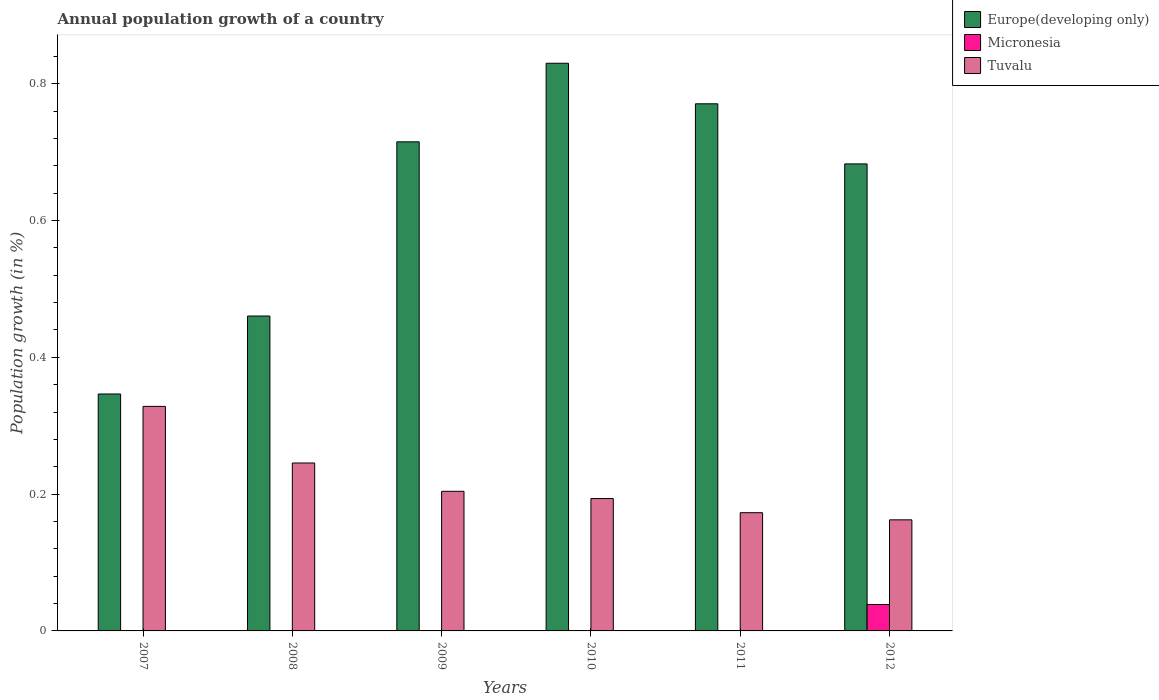How many different coloured bars are there?
Offer a terse response. 3. How many groups of bars are there?
Keep it short and to the point. 6. Are the number of bars per tick equal to the number of legend labels?
Ensure brevity in your answer.  No. How many bars are there on the 5th tick from the left?
Your answer should be compact. 2. What is the annual population growth in Europe(developing only) in 2009?
Offer a very short reply. 0.72. Across all years, what is the maximum annual population growth in Europe(developing only)?
Offer a terse response. 0.83. Across all years, what is the minimum annual population growth in Tuvalu?
Ensure brevity in your answer.  0.16. What is the total annual population growth in Micronesia in the graph?
Your answer should be very brief. 0.04. What is the difference between the annual population growth in Europe(developing only) in 2008 and that in 2009?
Your response must be concise. -0.25. What is the difference between the annual population growth in Micronesia in 2009 and the annual population growth in Europe(developing only) in 2012?
Ensure brevity in your answer.  -0.68. What is the average annual population growth in Micronesia per year?
Your answer should be very brief. 0.01. In the year 2007, what is the difference between the annual population growth in Tuvalu and annual population growth in Europe(developing only)?
Offer a terse response. -0.02. What is the ratio of the annual population growth in Tuvalu in 2007 to that in 2009?
Ensure brevity in your answer.  1.61. Is the annual population growth in Europe(developing only) in 2007 less than that in 2009?
Ensure brevity in your answer.  Yes. Is the difference between the annual population growth in Tuvalu in 2008 and 2010 greater than the difference between the annual population growth in Europe(developing only) in 2008 and 2010?
Offer a terse response. Yes. What is the difference between the highest and the second highest annual population growth in Europe(developing only)?
Provide a short and direct response. 0.06. What is the difference between the highest and the lowest annual population growth in Tuvalu?
Ensure brevity in your answer.  0.17. In how many years, is the annual population growth in Micronesia greater than the average annual population growth in Micronesia taken over all years?
Ensure brevity in your answer.  1. Is it the case that in every year, the sum of the annual population growth in Europe(developing only) and annual population growth in Tuvalu is greater than the annual population growth in Micronesia?
Offer a terse response. Yes. Are all the bars in the graph horizontal?
Keep it short and to the point. No. How many years are there in the graph?
Offer a terse response. 6. What is the title of the graph?
Offer a terse response. Annual population growth of a country. What is the label or title of the X-axis?
Your answer should be compact. Years. What is the label or title of the Y-axis?
Your answer should be compact. Population growth (in %). What is the Population growth (in %) of Europe(developing only) in 2007?
Your answer should be compact. 0.35. What is the Population growth (in %) in Micronesia in 2007?
Provide a succinct answer. 0. What is the Population growth (in %) of Tuvalu in 2007?
Provide a short and direct response. 0.33. What is the Population growth (in %) of Europe(developing only) in 2008?
Provide a short and direct response. 0.46. What is the Population growth (in %) in Tuvalu in 2008?
Your answer should be very brief. 0.25. What is the Population growth (in %) in Europe(developing only) in 2009?
Make the answer very short. 0.72. What is the Population growth (in %) of Tuvalu in 2009?
Offer a very short reply. 0.2. What is the Population growth (in %) in Europe(developing only) in 2010?
Your answer should be compact. 0.83. What is the Population growth (in %) of Micronesia in 2010?
Make the answer very short. 0. What is the Population growth (in %) in Tuvalu in 2010?
Give a very brief answer. 0.19. What is the Population growth (in %) of Europe(developing only) in 2011?
Your answer should be very brief. 0.77. What is the Population growth (in %) of Tuvalu in 2011?
Your response must be concise. 0.17. What is the Population growth (in %) in Europe(developing only) in 2012?
Ensure brevity in your answer.  0.68. What is the Population growth (in %) in Micronesia in 2012?
Your answer should be very brief. 0.04. What is the Population growth (in %) of Tuvalu in 2012?
Offer a terse response. 0.16. Across all years, what is the maximum Population growth (in %) in Europe(developing only)?
Ensure brevity in your answer.  0.83. Across all years, what is the maximum Population growth (in %) in Micronesia?
Offer a very short reply. 0.04. Across all years, what is the maximum Population growth (in %) of Tuvalu?
Your answer should be compact. 0.33. Across all years, what is the minimum Population growth (in %) in Europe(developing only)?
Keep it short and to the point. 0.35. Across all years, what is the minimum Population growth (in %) of Tuvalu?
Offer a terse response. 0.16. What is the total Population growth (in %) of Europe(developing only) in the graph?
Keep it short and to the point. 3.81. What is the total Population growth (in %) of Micronesia in the graph?
Keep it short and to the point. 0.04. What is the total Population growth (in %) in Tuvalu in the graph?
Provide a succinct answer. 1.31. What is the difference between the Population growth (in %) in Europe(developing only) in 2007 and that in 2008?
Your response must be concise. -0.11. What is the difference between the Population growth (in %) of Tuvalu in 2007 and that in 2008?
Your answer should be compact. 0.08. What is the difference between the Population growth (in %) in Europe(developing only) in 2007 and that in 2009?
Your answer should be compact. -0.37. What is the difference between the Population growth (in %) of Tuvalu in 2007 and that in 2009?
Your response must be concise. 0.12. What is the difference between the Population growth (in %) in Europe(developing only) in 2007 and that in 2010?
Your answer should be compact. -0.48. What is the difference between the Population growth (in %) of Tuvalu in 2007 and that in 2010?
Offer a terse response. 0.13. What is the difference between the Population growth (in %) of Europe(developing only) in 2007 and that in 2011?
Provide a succinct answer. -0.42. What is the difference between the Population growth (in %) of Tuvalu in 2007 and that in 2011?
Provide a short and direct response. 0.16. What is the difference between the Population growth (in %) in Europe(developing only) in 2007 and that in 2012?
Your answer should be compact. -0.34. What is the difference between the Population growth (in %) in Tuvalu in 2007 and that in 2012?
Make the answer very short. 0.17. What is the difference between the Population growth (in %) in Europe(developing only) in 2008 and that in 2009?
Your response must be concise. -0.25. What is the difference between the Population growth (in %) in Tuvalu in 2008 and that in 2009?
Make the answer very short. 0.04. What is the difference between the Population growth (in %) of Europe(developing only) in 2008 and that in 2010?
Ensure brevity in your answer.  -0.37. What is the difference between the Population growth (in %) in Tuvalu in 2008 and that in 2010?
Provide a short and direct response. 0.05. What is the difference between the Population growth (in %) in Europe(developing only) in 2008 and that in 2011?
Your answer should be compact. -0.31. What is the difference between the Population growth (in %) in Tuvalu in 2008 and that in 2011?
Offer a very short reply. 0.07. What is the difference between the Population growth (in %) of Europe(developing only) in 2008 and that in 2012?
Offer a terse response. -0.22. What is the difference between the Population growth (in %) of Tuvalu in 2008 and that in 2012?
Your answer should be very brief. 0.08. What is the difference between the Population growth (in %) of Europe(developing only) in 2009 and that in 2010?
Keep it short and to the point. -0.11. What is the difference between the Population growth (in %) in Tuvalu in 2009 and that in 2010?
Your response must be concise. 0.01. What is the difference between the Population growth (in %) in Europe(developing only) in 2009 and that in 2011?
Give a very brief answer. -0.06. What is the difference between the Population growth (in %) of Tuvalu in 2009 and that in 2011?
Your response must be concise. 0.03. What is the difference between the Population growth (in %) in Europe(developing only) in 2009 and that in 2012?
Offer a very short reply. 0.03. What is the difference between the Population growth (in %) in Tuvalu in 2009 and that in 2012?
Offer a very short reply. 0.04. What is the difference between the Population growth (in %) of Europe(developing only) in 2010 and that in 2011?
Your answer should be very brief. 0.06. What is the difference between the Population growth (in %) of Tuvalu in 2010 and that in 2011?
Provide a short and direct response. 0.02. What is the difference between the Population growth (in %) of Europe(developing only) in 2010 and that in 2012?
Your response must be concise. 0.15. What is the difference between the Population growth (in %) in Tuvalu in 2010 and that in 2012?
Give a very brief answer. 0.03. What is the difference between the Population growth (in %) of Europe(developing only) in 2011 and that in 2012?
Your response must be concise. 0.09. What is the difference between the Population growth (in %) in Tuvalu in 2011 and that in 2012?
Your answer should be compact. 0.01. What is the difference between the Population growth (in %) of Europe(developing only) in 2007 and the Population growth (in %) of Tuvalu in 2008?
Offer a terse response. 0.1. What is the difference between the Population growth (in %) of Europe(developing only) in 2007 and the Population growth (in %) of Tuvalu in 2009?
Your answer should be compact. 0.14. What is the difference between the Population growth (in %) in Europe(developing only) in 2007 and the Population growth (in %) in Tuvalu in 2010?
Give a very brief answer. 0.15. What is the difference between the Population growth (in %) of Europe(developing only) in 2007 and the Population growth (in %) of Tuvalu in 2011?
Keep it short and to the point. 0.17. What is the difference between the Population growth (in %) of Europe(developing only) in 2007 and the Population growth (in %) of Micronesia in 2012?
Offer a very short reply. 0.31. What is the difference between the Population growth (in %) of Europe(developing only) in 2007 and the Population growth (in %) of Tuvalu in 2012?
Your answer should be very brief. 0.18. What is the difference between the Population growth (in %) in Europe(developing only) in 2008 and the Population growth (in %) in Tuvalu in 2009?
Make the answer very short. 0.26. What is the difference between the Population growth (in %) in Europe(developing only) in 2008 and the Population growth (in %) in Tuvalu in 2010?
Your answer should be compact. 0.27. What is the difference between the Population growth (in %) in Europe(developing only) in 2008 and the Population growth (in %) in Tuvalu in 2011?
Your response must be concise. 0.29. What is the difference between the Population growth (in %) in Europe(developing only) in 2008 and the Population growth (in %) in Micronesia in 2012?
Make the answer very short. 0.42. What is the difference between the Population growth (in %) in Europe(developing only) in 2008 and the Population growth (in %) in Tuvalu in 2012?
Make the answer very short. 0.3. What is the difference between the Population growth (in %) of Europe(developing only) in 2009 and the Population growth (in %) of Tuvalu in 2010?
Your response must be concise. 0.52. What is the difference between the Population growth (in %) in Europe(developing only) in 2009 and the Population growth (in %) in Tuvalu in 2011?
Your answer should be very brief. 0.54. What is the difference between the Population growth (in %) of Europe(developing only) in 2009 and the Population growth (in %) of Micronesia in 2012?
Your answer should be very brief. 0.68. What is the difference between the Population growth (in %) in Europe(developing only) in 2009 and the Population growth (in %) in Tuvalu in 2012?
Ensure brevity in your answer.  0.55. What is the difference between the Population growth (in %) in Europe(developing only) in 2010 and the Population growth (in %) in Tuvalu in 2011?
Make the answer very short. 0.66. What is the difference between the Population growth (in %) in Europe(developing only) in 2010 and the Population growth (in %) in Micronesia in 2012?
Your answer should be very brief. 0.79. What is the difference between the Population growth (in %) in Europe(developing only) in 2010 and the Population growth (in %) in Tuvalu in 2012?
Give a very brief answer. 0.67. What is the difference between the Population growth (in %) in Europe(developing only) in 2011 and the Population growth (in %) in Micronesia in 2012?
Provide a succinct answer. 0.73. What is the difference between the Population growth (in %) in Europe(developing only) in 2011 and the Population growth (in %) in Tuvalu in 2012?
Ensure brevity in your answer.  0.61. What is the average Population growth (in %) in Europe(developing only) per year?
Your response must be concise. 0.63. What is the average Population growth (in %) of Micronesia per year?
Make the answer very short. 0.01. What is the average Population growth (in %) in Tuvalu per year?
Provide a succinct answer. 0.22. In the year 2007, what is the difference between the Population growth (in %) of Europe(developing only) and Population growth (in %) of Tuvalu?
Keep it short and to the point. 0.02. In the year 2008, what is the difference between the Population growth (in %) of Europe(developing only) and Population growth (in %) of Tuvalu?
Your answer should be very brief. 0.21. In the year 2009, what is the difference between the Population growth (in %) of Europe(developing only) and Population growth (in %) of Tuvalu?
Your answer should be very brief. 0.51. In the year 2010, what is the difference between the Population growth (in %) in Europe(developing only) and Population growth (in %) in Tuvalu?
Your answer should be compact. 0.64. In the year 2011, what is the difference between the Population growth (in %) in Europe(developing only) and Population growth (in %) in Tuvalu?
Offer a very short reply. 0.6. In the year 2012, what is the difference between the Population growth (in %) in Europe(developing only) and Population growth (in %) in Micronesia?
Provide a succinct answer. 0.64. In the year 2012, what is the difference between the Population growth (in %) in Europe(developing only) and Population growth (in %) in Tuvalu?
Keep it short and to the point. 0.52. In the year 2012, what is the difference between the Population growth (in %) of Micronesia and Population growth (in %) of Tuvalu?
Keep it short and to the point. -0.12. What is the ratio of the Population growth (in %) in Europe(developing only) in 2007 to that in 2008?
Provide a short and direct response. 0.75. What is the ratio of the Population growth (in %) of Tuvalu in 2007 to that in 2008?
Offer a terse response. 1.34. What is the ratio of the Population growth (in %) of Europe(developing only) in 2007 to that in 2009?
Offer a terse response. 0.48. What is the ratio of the Population growth (in %) in Tuvalu in 2007 to that in 2009?
Provide a succinct answer. 1.61. What is the ratio of the Population growth (in %) in Europe(developing only) in 2007 to that in 2010?
Provide a succinct answer. 0.42. What is the ratio of the Population growth (in %) in Tuvalu in 2007 to that in 2010?
Provide a short and direct response. 1.7. What is the ratio of the Population growth (in %) in Europe(developing only) in 2007 to that in 2011?
Give a very brief answer. 0.45. What is the ratio of the Population growth (in %) in Tuvalu in 2007 to that in 2011?
Ensure brevity in your answer.  1.9. What is the ratio of the Population growth (in %) of Europe(developing only) in 2007 to that in 2012?
Provide a succinct answer. 0.51. What is the ratio of the Population growth (in %) in Tuvalu in 2007 to that in 2012?
Offer a very short reply. 2.02. What is the ratio of the Population growth (in %) of Europe(developing only) in 2008 to that in 2009?
Offer a terse response. 0.64. What is the ratio of the Population growth (in %) of Tuvalu in 2008 to that in 2009?
Offer a terse response. 1.2. What is the ratio of the Population growth (in %) in Europe(developing only) in 2008 to that in 2010?
Your answer should be very brief. 0.55. What is the ratio of the Population growth (in %) in Tuvalu in 2008 to that in 2010?
Offer a terse response. 1.27. What is the ratio of the Population growth (in %) in Europe(developing only) in 2008 to that in 2011?
Keep it short and to the point. 0.6. What is the ratio of the Population growth (in %) in Tuvalu in 2008 to that in 2011?
Give a very brief answer. 1.42. What is the ratio of the Population growth (in %) in Europe(developing only) in 2008 to that in 2012?
Make the answer very short. 0.67. What is the ratio of the Population growth (in %) in Tuvalu in 2008 to that in 2012?
Offer a terse response. 1.51. What is the ratio of the Population growth (in %) of Europe(developing only) in 2009 to that in 2010?
Ensure brevity in your answer.  0.86. What is the ratio of the Population growth (in %) in Tuvalu in 2009 to that in 2010?
Your response must be concise. 1.05. What is the ratio of the Population growth (in %) of Europe(developing only) in 2009 to that in 2011?
Offer a very short reply. 0.93. What is the ratio of the Population growth (in %) in Tuvalu in 2009 to that in 2011?
Your answer should be very brief. 1.18. What is the ratio of the Population growth (in %) of Europe(developing only) in 2009 to that in 2012?
Offer a very short reply. 1.05. What is the ratio of the Population growth (in %) in Tuvalu in 2009 to that in 2012?
Keep it short and to the point. 1.26. What is the ratio of the Population growth (in %) in Tuvalu in 2010 to that in 2011?
Ensure brevity in your answer.  1.12. What is the ratio of the Population growth (in %) in Europe(developing only) in 2010 to that in 2012?
Ensure brevity in your answer.  1.22. What is the ratio of the Population growth (in %) of Tuvalu in 2010 to that in 2012?
Your answer should be compact. 1.19. What is the ratio of the Population growth (in %) of Europe(developing only) in 2011 to that in 2012?
Your response must be concise. 1.13. What is the ratio of the Population growth (in %) of Tuvalu in 2011 to that in 2012?
Offer a terse response. 1.06. What is the difference between the highest and the second highest Population growth (in %) in Europe(developing only)?
Ensure brevity in your answer.  0.06. What is the difference between the highest and the second highest Population growth (in %) of Tuvalu?
Your response must be concise. 0.08. What is the difference between the highest and the lowest Population growth (in %) of Europe(developing only)?
Make the answer very short. 0.48. What is the difference between the highest and the lowest Population growth (in %) of Micronesia?
Make the answer very short. 0.04. What is the difference between the highest and the lowest Population growth (in %) in Tuvalu?
Offer a terse response. 0.17. 